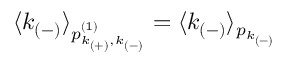Convert formula to latex. <formula><loc_0><loc_0><loc_500><loc_500>\langle k _ { ( - ) } \rangle _ { p _ { k _ { ( + ) } , k _ { ( - ) } } ^ { ( 1 ) } } = \langle k _ { ( - ) } \rangle _ { p _ { k _ { ( - ) } } }</formula> 